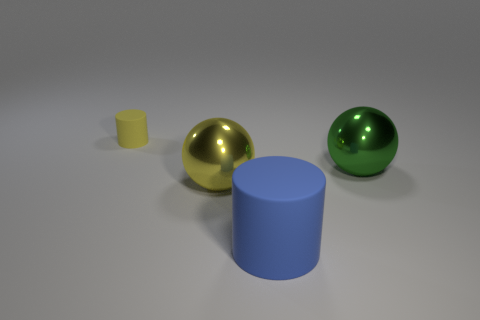Is there any other thing that has the same size as the yellow rubber cylinder?
Provide a short and direct response. No. There is a matte cylinder in front of the yellow matte object; what size is it?
Your answer should be very brief. Large. There is a big metal sphere that is to the right of the large yellow metal ball; does it have the same color as the small rubber thing?
Your response must be concise. No. How many other blue things are the same shape as the blue rubber thing?
Your answer should be very brief. 0. What number of things are either cylinders right of the tiny yellow rubber cylinder or cylinders that are in front of the small object?
Your answer should be compact. 1. How many blue objects are cylinders or small rubber cylinders?
Offer a very short reply. 1. What is the material of the thing that is both in front of the green metallic object and behind the large matte cylinder?
Your answer should be very brief. Metal. Is the material of the large yellow ball the same as the large green thing?
Give a very brief answer. Yes. How many rubber cylinders have the same size as the green metal object?
Make the answer very short. 1. Is the number of small matte objects that are in front of the large yellow thing the same as the number of big metal spheres?
Offer a very short reply. No. 